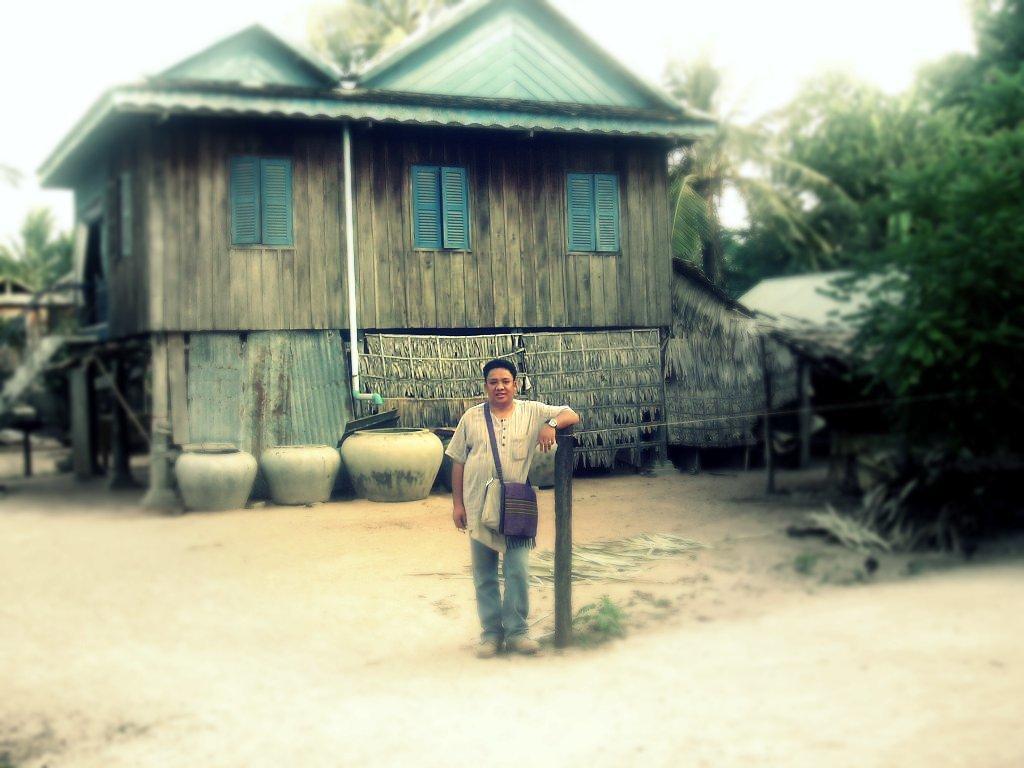Please provide a concise description of this image. In the middle of this image, there is a person, wearing a bag, placing a hand on a pole, on the ground. In front of him, there is a road. In the background, there are houses, trees and there are clouds in the sky. 